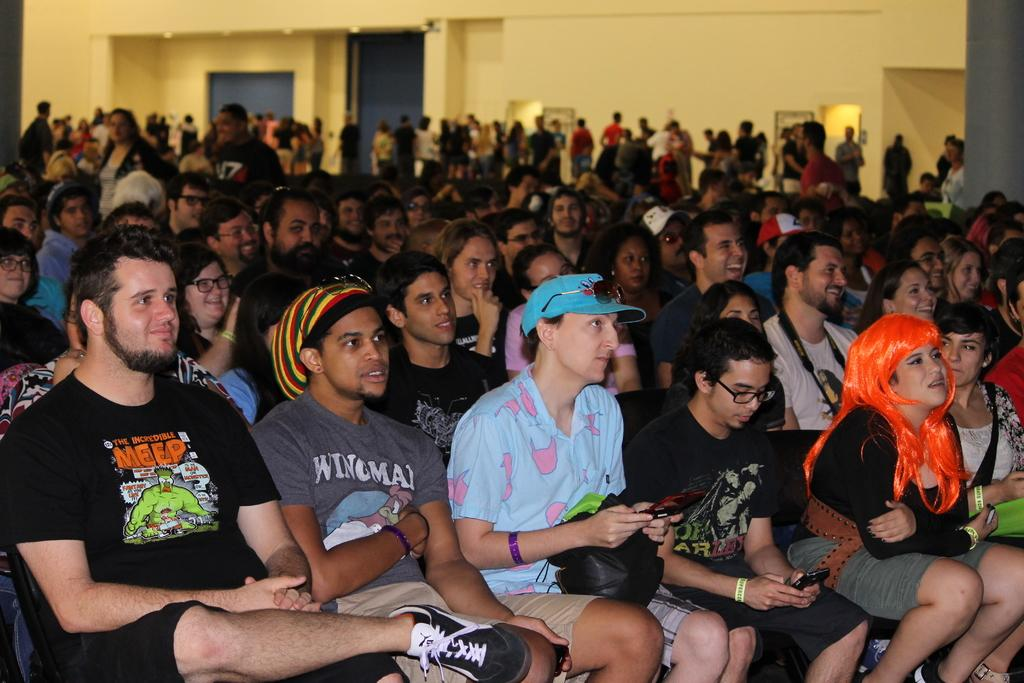What are the people in the image doing? There is a group of people sitting and a group of people standing in the image. What can be seen illuminating the scene in the image? There are lights visible in the image. What feature is present around the edges of the image? There are borders or frames in the image. What type of destruction is being caused by the trains in the image? There are no trains present in the image, so no destruction can be observed. 